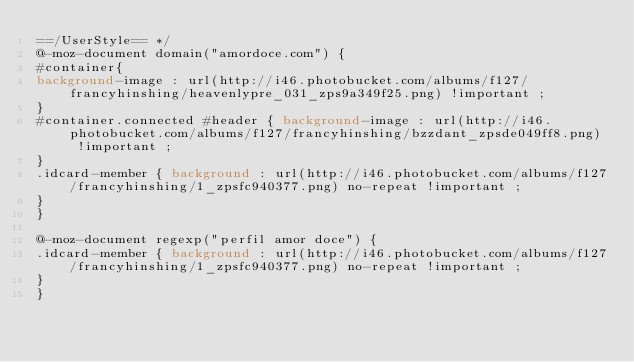<code> <loc_0><loc_0><loc_500><loc_500><_CSS_>==/UserStyle== */
@-moz-document domain("amordoce.com") {
#container{
background-image : url(http://i46.photobucket.com/albums/f127/francyhinshing/heavenlypre_031_zps9a349f25.png) !important ;
}
#container.connected #header { background-image : url(http://i46.photobucket.com/albums/f127/francyhinshing/bzzdant_zpsde049ff8.png) !important ;
}
.idcard-member { background : url(http://i46.photobucket.com/albums/f127/francyhinshing/1_zpsfc940377.png) no-repeat !important ;
}
}

@-moz-document regexp("perfil amor doce") {
.idcard-member { background : url(http://i46.photobucket.com/albums/f127/francyhinshing/1_zpsfc940377.png) no-repeat !important ;
}
}</code> 